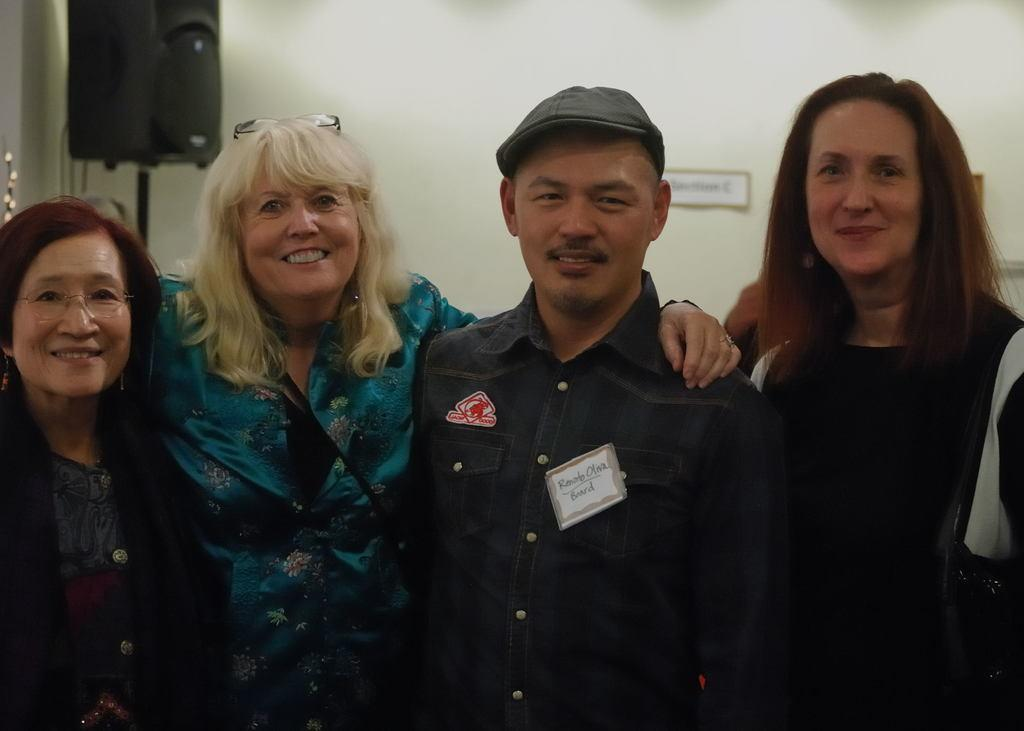Who or what is present in the image? There are people in the image. What are the people doing in the image? The people are smiling. What can be seen in the background or foreground of the image? There is a wall in the background or foreground of the image. What object is visible in the image that might be used for amplifying sound? There is a speaker in the image. What type of orange can be seen growing on the wall in the image? There is no orange or orange tree present in the image; the wall is a separate element in the background or foreground. 